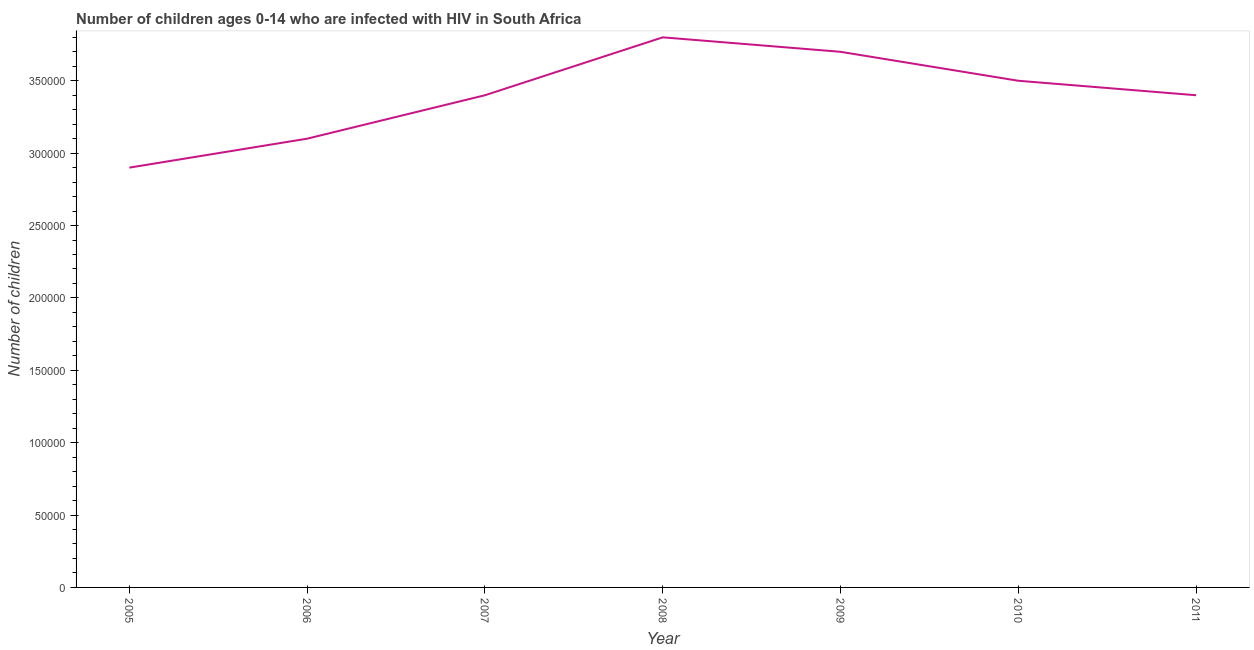What is the number of children living with hiv in 2010?
Keep it short and to the point. 3.50e+05. Across all years, what is the maximum number of children living with hiv?
Your answer should be compact. 3.80e+05. Across all years, what is the minimum number of children living with hiv?
Ensure brevity in your answer.  2.90e+05. In which year was the number of children living with hiv maximum?
Give a very brief answer. 2008. In which year was the number of children living with hiv minimum?
Provide a short and direct response. 2005. What is the sum of the number of children living with hiv?
Provide a short and direct response. 2.38e+06. What is the difference between the number of children living with hiv in 2005 and 2009?
Your response must be concise. -8.00e+04. What is the average number of children living with hiv per year?
Your answer should be very brief. 3.40e+05. In how many years, is the number of children living with hiv greater than 180000 ?
Give a very brief answer. 7. Do a majority of the years between 2006 and 2007 (inclusive) have number of children living with hiv greater than 150000 ?
Provide a succinct answer. Yes. What is the ratio of the number of children living with hiv in 2010 to that in 2011?
Your answer should be very brief. 1.03. What is the difference between the highest and the second highest number of children living with hiv?
Provide a succinct answer. 10000. Is the sum of the number of children living with hiv in 2010 and 2011 greater than the maximum number of children living with hiv across all years?
Ensure brevity in your answer.  Yes. What is the difference between the highest and the lowest number of children living with hiv?
Your response must be concise. 9.00e+04. In how many years, is the number of children living with hiv greater than the average number of children living with hiv taken over all years?
Your answer should be compact. 3. Does the number of children living with hiv monotonically increase over the years?
Provide a succinct answer. No. How many lines are there?
Offer a very short reply. 1. Does the graph contain any zero values?
Provide a succinct answer. No. What is the title of the graph?
Offer a terse response. Number of children ages 0-14 who are infected with HIV in South Africa. What is the label or title of the X-axis?
Make the answer very short. Year. What is the label or title of the Y-axis?
Offer a very short reply. Number of children. What is the Number of children in 2005?
Ensure brevity in your answer.  2.90e+05. What is the Number of children in 2006?
Ensure brevity in your answer.  3.10e+05. What is the Number of children of 2007?
Your answer should be very brief. 3.40e+05. What is the Number of children in 2008?
Keep it short and to the point. 3.80e+05. What is the Number of children in 2009?
Make the answer very short. 3.70e+05. What is the difference between the Number of children in 2005 and 2006?
Your answer should be compact. -2.00e+04. What is the difference between the Number of children in 2005 and 2007?
Offer a terse response. -5.00e+04. What is the difference between the Number of children in 2005 and 2008?
Offer a terse response. -9.00e+04. What is the difference between the Number of children in 2005 and 2011?
Give a very brief answer. -5.00e+04. What is the difference between the Number of children in 2006 and 2007?
Your answer should be very brief. -3.00e+04. What is the difference between the Number of children in 2006 and 2009?
Give a very brief answer. -6.00e+04. What is the difference between the Number of children in 2006 and 2010?
Give a very brief answer. -4.00e+04. What is the difference between the Number of children in 2007 and 2008?
Make the answer very short. -4.00e+04. What is the difference between the Number of children in 2007 and 2009?
Keep it short and to the point. -3.00e+04. What is the difference between the Number of children in 2008 and 2011?
Your answer should be very brief. 4.00e+04. What is the difference between the Number of children in 2010 and 2011?
Offer a very short reply. 10000. What is the ratio of the Number of children in 2005 to that in 2006?
Offer a very short reply. 0.94. What is the ratio of the Number of children in 2005 to that in 2007?
Keep it short and to the point. 0.85. What is the ratio of the Number of children in 2005 to that in 2008?
Give a very brief answer. 0.76. What is the ratio of the Number of children in 2005 to that in 2009?
Offer a very short reply. 0.78. What is the ratio of the Number of children in 2005 to that in 2010?
Provide a succinct answer. 0.83. What is the ratio of the Number of children in 2005 to that in 2011?
Your answer should be compact. 0.85. What is the ratio of the Number of children in 2006 to that in 2007?
Make the answer very short. 0.91. What is the ratio of the Number of children in 2006 to that in 2008?
Offer a very short reply. 0.82. What is the ratio of the Number of children in 2006 to that in 2009?
Make the answer very short. 0.84. What is the ratio of the Number of children in 2006 to that in 2010?
Make the answer very short. 0.89. What is the ratio of the Number of children in 2006 to that in 2011?
Your answer should be very brief. 0.91. What is the ratio of the Number of children in 2007 to that in 2008?
Your answer should be compact. 0.9. What is the ratio of the Number of children in 2007 to that in 2009?
Offer a very short reply. 0.92. What is the ratio of the Number of children in 2007 to that in 2010?
Provide a succinct answer. 0.97. What is the ratio of the Number of children in 2007 to that in 2011?
Ensure brevity in your answer.  1. What is the ratio of the Number of children in 2008 to that in 2009?
Provide a short and direct response. 1.03. What is the ratio of the Number of children in 2008 to that in 2010?
Make the answer very short. 1.09. What is the ratio of the Number of children in 2008 to that in 2011?
Provide a short and direct response. 1.12. What is the ratio of the Number of children in 2009 to that in 2010?
Your response must be concise. 1.06. What is the ratio of the Number of children in 2009 to that in 2011?
Your answer should be very brief. 1.09. What is the ratio of the Number of children in 2010 to that in 2011?
Offer a very short reply. 1.03. 